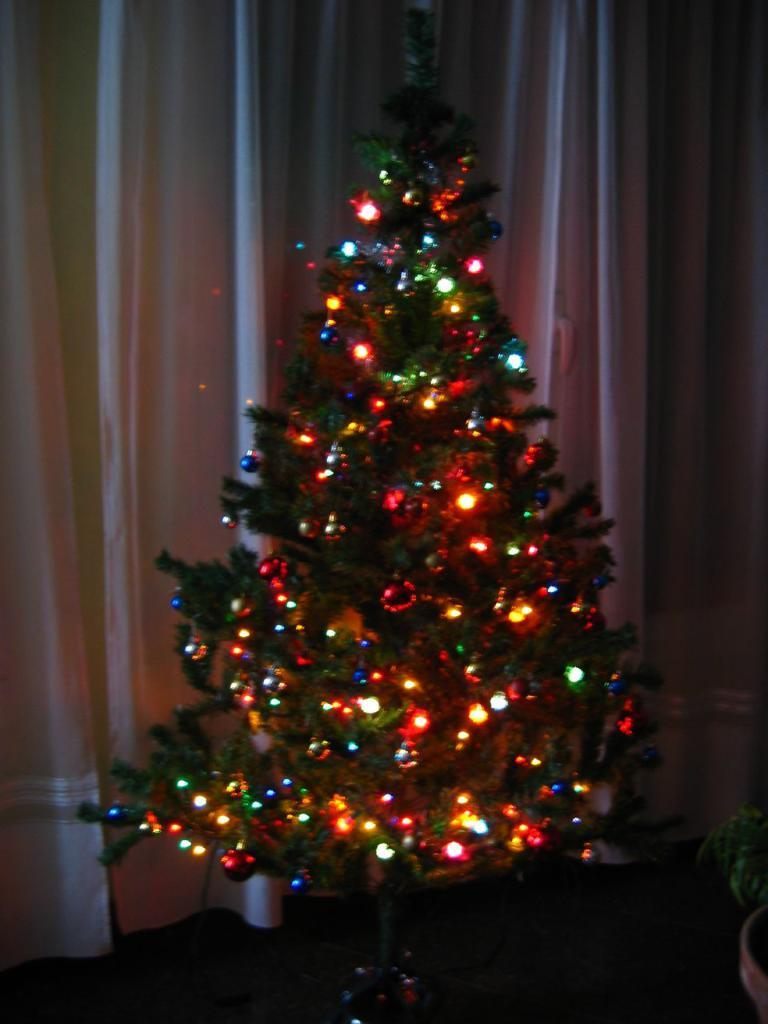What is the main subject of the image? The main subject of the image is a Christmas tree. What feature of the Christmas tree is mentioned in the facts? The Christmas tree has decorative lights. What else can be seen in the image besides the Christmas tree? There is a curtain visible in the image, and there is an object that looks like a potted plant. What scent can be detected in the image? There is no mention of a scent in the image. The image only shows a Christmas tree with decorative lights, a curtain, and an object that looks like a potted plant. 